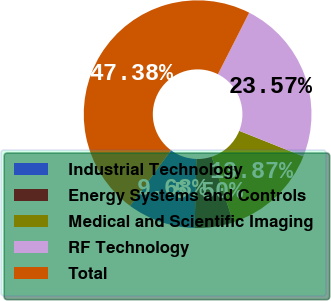Convert chart. <chart><loc_0><loc_0><loc_500><loc_500><pie_chart><fcel>Industrial Technology<fcel>Energy Systems and Controls<fcel>Medical and Scientific Imaging<fcel>RF Technology<fcel>Total<nl><fcel>9.68%<fcel>5.5%<fcel>13.87%<fcel>23.57%<fcel>47.38%<nl></chart> 